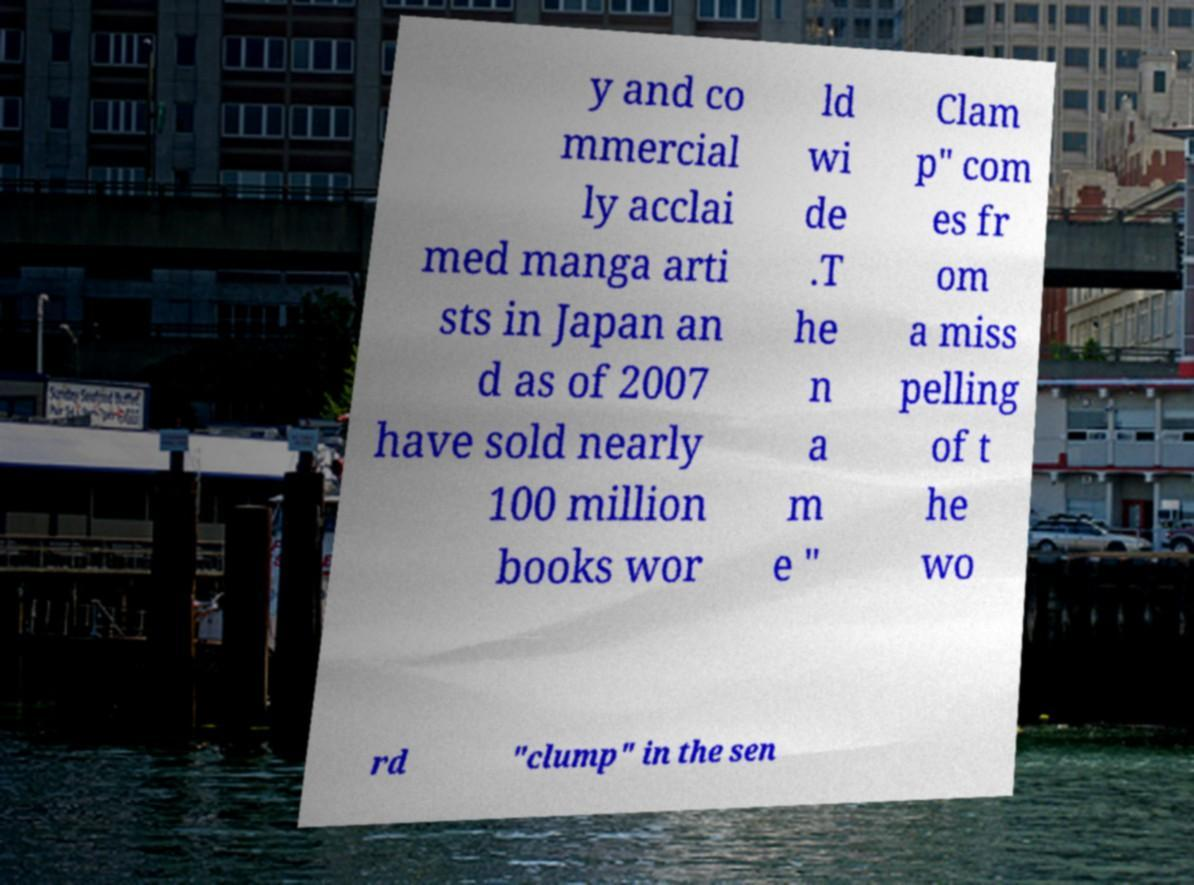Can you read and provide the text displayed in the image?This photo seems to have some interesting text. Can you extract and type it out for me? y and co mmercial ly acclai med manga arti sts in Japan an d as of 2007 have sold nearly 100 million books wor ld wi de .T he n a m e " Clam p" com es fr om a miss pelling of t he wo rd "clump" in the sen 